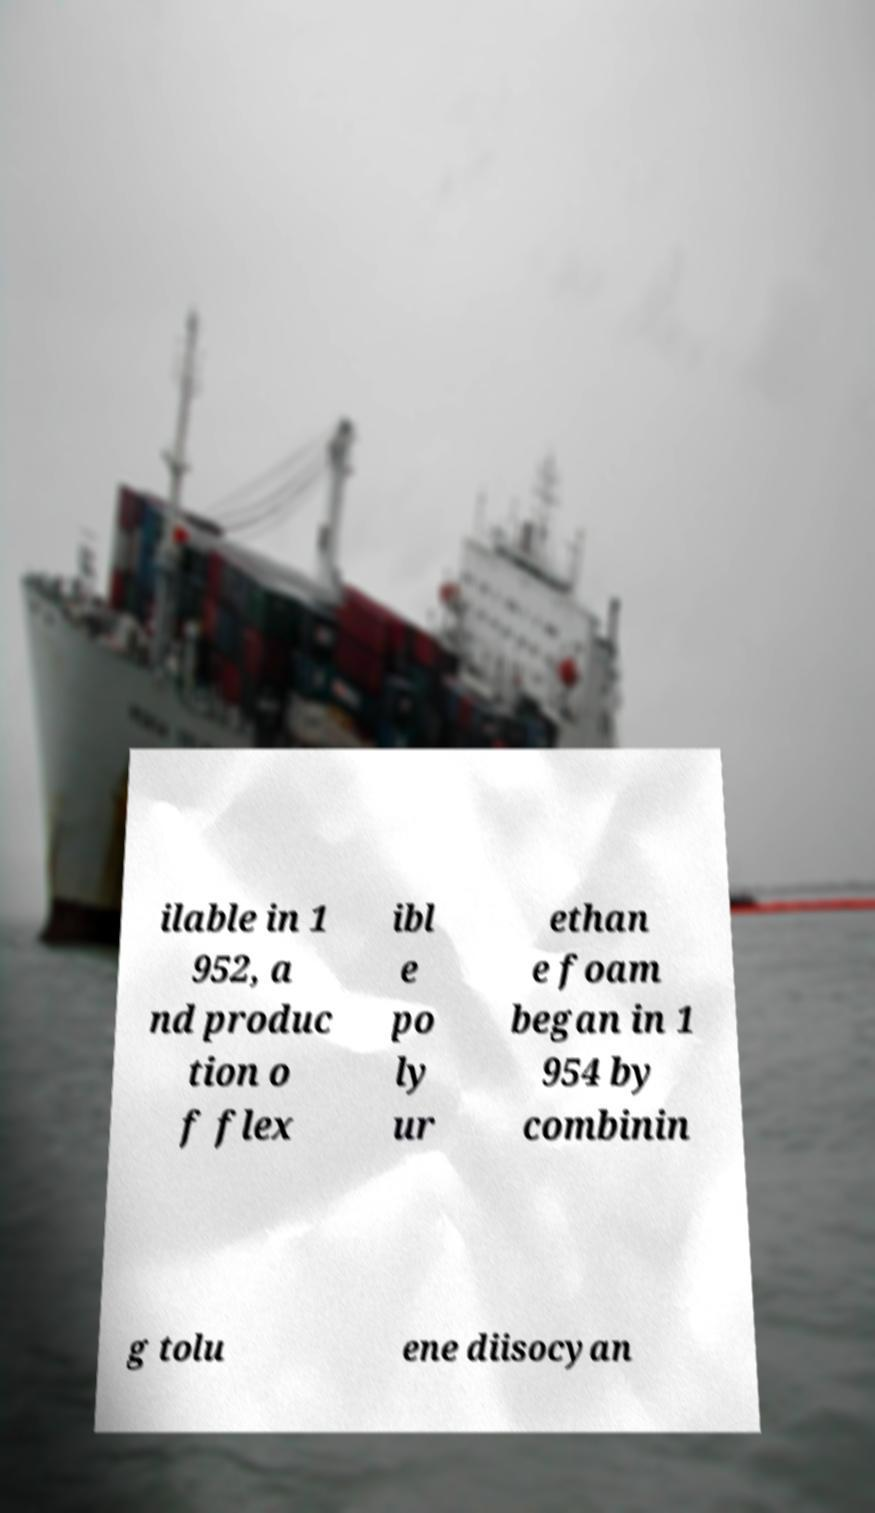For documentation purposes, I need the text within this image transcribed. Could you provide that? ilable in 1 952, a nd produc tion o f flex ibl e po ly ur ethan e foam began in 1 954 by combinin g tolu ene diisocyan 